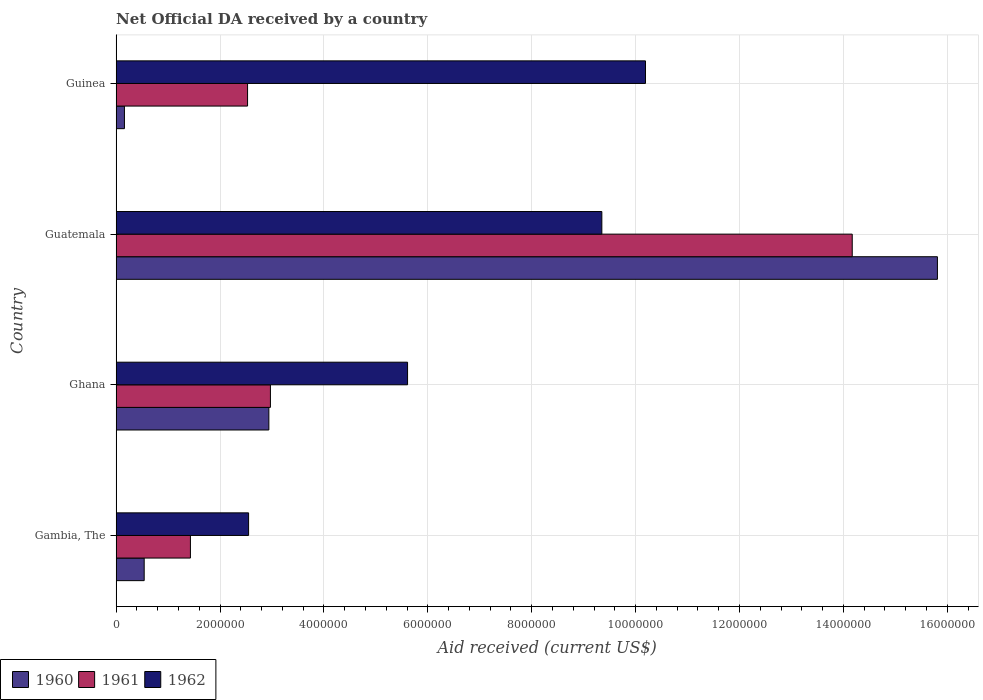How many groups of bars are there?
Provide a short and direct response. 4. Are the number of bars per tick equal to the number of legend labels?
Your response must be concise. Yes. What is the label of the 2nd group of bars from the top?
Your answer should be compact. Guatemala. In how many cases, is the number of bars for a given country not equal to the number of legend labels?
Provide a succinct answer. 0. What is the net official development assistance aid received in 1960 in Guatemala?
Offer a very short reply. 1.58e+07. Across all countries, what is the maximum net official development assistance aid received in 1961?
Your answer should be compact. 1.42e+07. Across all countries, what is the minimum net official development assistance aid received in 1961?
Keep it short and to the point. 1.43e+06. In which country was the net official development assistance aid received in 1962 maximum?
Provide a short and direct response. Guinea. In which country was the net official development assistance aid received in 1961 minimum?
Your answer should be very brief. Gambia, The. What is the total net official development assistance aid received in 1961 in the graph?
Provide a short and direct response. 2.11e+07. What is the difference between the net official development assistance aid received in 1961 in Gambia, The and that in Guatemala?
Your answer should be compact. -1.27e+07. What is the difference between the net official development assistance aid received in 1960 in Gambia, The and the net official development assistance aid received in 1962 in Guinea?
Ensure brevity in your answer.  -9.65e+06. What is the average net official development assistance aid received in 1962 per country?
Offer a terse response. 6.92e+06. What is the difference between the net official development assistance aid received in 1961 and net official development assistance aid received in 1962 in Guinea?
Provide a succinct answer. -7.66e+06. What is the ratio of the net official development assistance aid received in 1961 in Ghana to that in Guatemala?
Provide a succinct answer. 0.21. Is the net official development assistance aid received in 1961 in Ghana less than that in Guinea?
Provide a short and direct response. No. What is the difference between the highest and the second highest net official development assistance aid received in 1962?
Your response must be concise. 8.40e+05. What is the difference between the highest and the lowest net official development assistance aid received in 1960?
Your answer should be very brief. 1.56e+07. Is the sum of the net official development assistance aid received in 1960 in Ghana and Guatemala greater than the maximum net official development assistance aid received in 1962 across all countries?
Provide a succinct answer. Yes. What does the 3rd bar from the bottom in Guatemala represents?
Offer a terse response. 1962. Is it the case that in every country, the sum of the net official development assistance aid received in 1961 and net official development assistance aid received in 1962 is greater than the net official development assistance aid received in 1960?
Offer a very short reply. Yes. Does the graph contain grids?
Your answer should be compact. Yes. Where does the legend appear in the graph?
Make the answer very short. Bottom left. How are the legend labels stacked?
Ensure brevity in your answer.  Horizontal. What is the title of the graph?
Make the answer very short. Net Official DA received by a country. Does "2010" appear as one of the legend labels in the graph?
Give a very brief answer. No. What is the label or title of the X-axis?
Offer a very short reply. Aid received (current US$). What is the Aid received (current US$) in 1960 in Gambia, The?
Keep it short and to the point. 5.40e+05. What is the Aid received (current US$) in 1961 in Gambia, The?
Offer a very short reply. 1.43e+06. What is the Aid received (current US$) of 1962 in Gambia, The?
Offer a very short reply. 2.55e+06. What is the Aid received (current US$) in 1960 in Ghana?
Offer a terse response. 2.94e+06. What is the Aid received (current US$) in 1961 in Ghana?
Provide a succinct answer. 2.97e+06. What is the Aid received (current US$) in 1962 in Ghana?
Keep it short and to the point. 5.61e+06. What is the Aid received (current US$) of 1960 in Guatemala?
Make the answer very short. 1.58e+07. What is the Aid received (current US$) in 1961 in Guatemala?
Provide a succinct answer. 1.42e+07. What is the Aid received (current US$) in 1962 in Guatemala?
Keep it short and to the point. 9.35e+06. What is the Aid received (current US$) of 1960 in Guinea?
Your answer should be compact. 1.60e+05. What is the Aid received (current US$) in 1961 in Guinea?
Offer a very short reply. 2.53e+06. What is the Aid received (current US$) of 1962 in Guinea?
Keep it short and to the point. 1.02e+07. Across all countries, what is the maximum Aid received (current US$) in 1960?
Give a very brief answer. 1.58e+07. Across all countries, what is the maximum Aid received (current US$) of 1961?
Your response must be concise. 1.42e+07. Across all countries, what is the maximum Aid received (current US$) in 1962?
Keep it short and to the point. 1.02e+07. Across all countries, what is the minimum Aid received (current US$) of 1960?
Keep it short and to the point. 1.60e+05. Across all countries, what is the minimum Aid received (current US$) of 1961?
Your response must be concise. 1.43e+06. Across all countries, what is the minimum Aid received (current US$) of 1962?
Provide a succinct answer. 2.55e+06. What is the total Aid received (current US$) of 1960 in the graph?
Your answer should be very brief. 1.94e+07. What is the total Aid received (current US$) in 1961 in the graph?
Provide a succinct answer. 2.11e+07. What is the total Aid received (current US$) in 1962 in the graph?
Ensure brevity in your answer.  2.77e+07. What is the difference between the Aid received (current US$) of 1960 in Gambia, The and that in Ghana?
Offer a terse response. -2.40e+06. What is the difference between the Aid received (current US$) of 1961 in Gambia, The and that in Ghana?
Give a very brief answer. -1.54e+06. What is the difference between the Aid received (current US$) of 1962 in Gambia, The and that in Ghana?
Provide a succinct answer. -3.06e+06. What is the difference between the Aid received (current US$) in 1960 in Gambia, The and that in Guatemala?
Make the answer very short. -1.53e+07. What is the difference between the Aid received (current US$) of 1961 in Gambia, The and that in Guatemala?
Provide a short and direct response. -1.27e+07. What is the difference between the Aid received (current US$) of 1962 in Gambia, The and that in Guatemala?
Keep it short and to the point. -6.80e+06. What is the difference between the Aid received (current US$) in 1960 in Gambia, The and that in Guinea?
Offer a terse response. 3.80e+05. What is the difference between the Aid received (current US$) in 1961 in Gambia, The and that in Guinea?
Your answer should be very brief. -1.10e+06. What is the difference between the Aid received (current US$) in 1962 in Gambia, The and that in Guinea?
Keep it short and to the point. -7.64e+06. What is the difference between the Aid received (current US$) in 1960 in Ghana and that in Guatemala?
Give a very brief answer. -1.29e+07. What is the difference between the Aid received (current US$) in 1961 in Ghana and that in Guatemala?
Provide a short and direct response. -1.12e+07. What is the difference between the Aid received (current US$) of 1962 in Ghana and that in Guatemala?
Your answer should be very brief. -3.74e+06. What is the difference between the Aid received (current US$) in 1960 in Ghana and that in Guinea?
Provide a short and direct response. 2.78e+06. What is the difference between the Aid received (current US$) in 1962 in Ghana and that in Guinea?
Your response must be concise. -4.58e+06. What is the difference between the Aid received (current US$) in 1960 in Guatemala and that in Guinea?
Ensure brevity in your answer.  1.56e+07. What is the difference between the Aid received (current US$) in 1961 in Guatemala and that in Guinea?
Your answer should be very brief. 1.16e+07. What is the difference between the Aid received (current US$) of 1962 in Guatemala and that in Guinea?
Make the answer very short. -8.40e+05. What is the difference between the Aid received (current US$) in 1960 in Gambia, The and the Aid received (current US$) in 1961 in Ghana?
Offer a terse response. -2.43e+06. What is the difference between the Aid received (current US$) in 1960 in Gambia, The and the Aid received (current US$) in 1962 in Ghana?
Give a very brief answer. -5.07e+06. What is the difference between the Aid received (current US$) in 1961 in Gambia, The and the Aid received (current US$) in 1962 in Ghana?
Your answer should be compact. -4.18e+06. What is the difference between the Aid received (current US$) in 1960 in Gambia, The and the Aid received (current US$) in 1961 in Guatemala?
Your response must be concise. -1.36e+07. What is the difference between the Aid received (current US$) of 1960 in Gambia, The and the Aid received (current US$) of 1962 in Guatemala?
Provide a short and direct response. -8.81e+06. What is the difference between the Aid received (current US$) in 1961 in Gambia, The and the Aid received (current US$) in 1962 in Guatemala?
Offer a terse response. -7.92e+06. What is the difference between the Aid received (current US$) in 1960 in Gambia, The and the Aid received (current US$) in 1961 in Guinea?
Offer a terse response. -1.99e+06. What is the difference between the Aid received (current US$) of 1960 in Gambia, The and the Aid received (current US$) of 1962 in Guinea?
Provide a succinct answer. -9.65e+06. What is the difference between the Aid received (current US$) in 1961 in Gambia, The and the Aid received (current US$) in 1962 in Guinea?
Keep it short and to the point. -8.76e+06. What is the difference between the Aid received (current US$) in 1960 in Ghana and the Aid received (current US$) in 1961 in Guatemala?
Your answer should be compact. -1.12e+07. What is the difference between the Aid received (current US$) in 1960 in Ghana and the Aid received (current US$) in 1962 in Guatemala?
Ensure brevity in your answer.  -6.41e+06. What is the difference between the Aid received (current US$) of 1961 in Ghana and the Aid received (current US$) of 1962 in Guatemala?
Keep it short and to the point. -6.38e+06. What is the difference between the Aid received (current US$) of 1960 in Ghana and the Aid received (current US$) of 1961 in Guinea?
Ensure brevity in your answer.  4.10e+05. What is the difference between the Aid received (current US$) of 1960 in Ghana and the Aid received (current US$) of 1962 in Guinea?
Your answer should be compact. -7.25e+06. What is the difference between the Aid received (current US$) of 1961 in Ghana and the Aid received (current US$) of 1962 in Guinea?
Your answer should be compact. -7.22e+06. What is the difference between the Aid received (current US$) of 1960 in Guatemala and the Aid received (current US$) of 1961 in Guinea?
Ensure brevity in your answer.  1.33e+07. What is the difference between the Aid received (current US$) in 1960 in Guatemala and the Aid received (current US$) in 1962 in Guinea?
Keep it short and to the point. 5.62e+06. What is the difference between the Aid received (current US$) of 1961 in Guatemala and the Aid received (current US$) of 1962 in Guinea?
Make the answer very short. 3.98e+06. What is the average Aid received (current US$) of 1960 per country?
Give a very brief answer. 4.86e+06. What is the average Aid received (current US$) of 1961 per country?
Your answer should be very brief. 5.28e+06. What is the average Aid received (current US$) of 1962 per country?
Give a very brief answer. 6.92e+06. What is the difference between the Aid received (current US$) in 1960 and Aid received (current US$) in 1961 in Gambia, The?
Ensure brevity in your answer.  -8.90e+05. What is the difference between the Aid received (current US$) of 1960 and Aid received (current US$) of 1962 in Gambia, The?
Make the answer very short. -2.01e+06. What is the difference between the Aid received (current US$) of 1961 and Aid received (current US$) of 1962 in Gambia, The?
Your answer should be compact. -1.12e+06. What is the difference between the Aid received (current US$) of 1960 and Aid received (current US$) of 1961 in Ghana?
Provide a short and direct response. -3.00e+04. What is the difference between the Aid received (current US$) in 1960 and Aid received (current US$) in 1962 in Ghana?
Your answer should be compact. -2.67e+06. What is the difference between the Aid received (current US$) in 1961 and Aid received (current US$) in 1962 in Ghana?
Provide a succinct answer. -2.64e+06. What is the difference between the Aid received (current US$) in 1960 and Aid received (current US$) in 1961 in Guatemala?
Give a very brief answer. 1.64e+06. What is the difference between the Aid received (current US$) of 1960 and Aid received (current US$) of 1962 in Guatemala?
Keep it short and to the point. 6.46e+06. What is the difference between the Aid received (current US$) of 1961 and Aid received (current US$) of 1962 in Guatemala?
Your response must be concise. 4.82e+06. What is the difference between the Aid received (current US$) in 1960 and Aid received (current US$) in 1961 in Guinea?
Keep it short and to the point. -2.37e+06. What is the difference between the Aid received (current US$) of 1960 and Aid received (current US$) of 1962 in Guinea?
Your response must be concise. -1.00e+07. What is the difference between the Aid received (current US$) of 1961 and Aid received (current US$) of 1962 in Guinea?
Offer a terse response. -7.66e+06. What is the ratio of the Aid received (current US$) in 1960 in Gambia, The to that in Ghana?
Give a very brief answer. 0.18. What is the ratio of the Aid received (current US$) of 1961 in Gambia, The to that in Ghana?
Make the answer very short. 0.48. What is the ratio of the Aid received (current US$) of 1962 in Gambia, The to that in Ghana?
Your answer should be very brief. 0.45. What is the ratio of the Aid received (current US$) of 1960 in Gambia, The to that in Guatemala?
Your answer should be very brief. 0.03. What is the ratio of the Aid received (current US$) of 1961 in Gambia, The to that in Guatemala?
Your answer should be compact. 0.1. What is the ratio of the Aid received (current US$) of 1962 in Gambia, The to that in Guatemala?
Your response must be concise. 0.27. What is the ratio of the Aid received (current US$) in 1960 in Gambia, The to that in Guinea?
Your response must be concise. 3.38. What is the ratio of the Aid received (current US$) of 1961 in Gambia, The to that in Guinea?
Your response must be concise. 0.57. What is the ratio of the Aid received (current US$) in 1962 in Gambia, The to that in Guinea?
Your response must be concise. 0.25. What is the ratio of the Aid received (current US$) of 1960 in Ghana to that in Guatemala?
Provide a short and direct response. 0.19. What is the ratio of the Aid received (current US$) in 1961 in Ghana to that in Guatemala?
Your answer should be compact. 0.21. What is the ratio of the Aid received (current US$) in 1960 in Ghana to that in Guinea?
Provide a short and direct response. 18.38. What is the ratio of the Aid received (current US$) of 1961 in Ghana to that in Guinea?
Offer a very short reply. 1.17. What is the ratio of the Aid received (current US$) in 1962 in Ghana to that in Guinea?
Provide a succinct answer. 0.55. What is the ratio of the Aid received (current US$) of 1960 in Guatemala to that in Guinea?
Ensure brevity in your answer.  98.81. What is the ratio of the Aid received (current US$) in 1961 in Guatemala to that in Guinea?
Make the answer very short. 5.6. What is the ratio of the Aid received (current US$) of 1962 in Guatemala to that in Guinea?
Ensure brevity in your answer.  0.92. What is the difference between the highest and the second highest Aid received (current US$) of 1960?
Offer a terse response. 1.29e+07. What is the difference between the highest and the second highest Aid received (current US$) of 1961?
Give a very brief answer. 1.12e+07. What is the difference between the highest and the second highest Aid received (current US$) of 1962?
Offer a terse response. 8.40e+05. What is the difference between the highest and the lowest Aid received (current US$) of 1960?
Your response must be concise. 1.56e+07. What is the difference between the highest and the lowest Aid received (current US$) of 1961?
Ensure brevity in your answer.  1.27e+07. What is the difference between the highest and the lowest Aid received (current US$) of 1962?
Your answer should be very brief. 7.64e+06. 